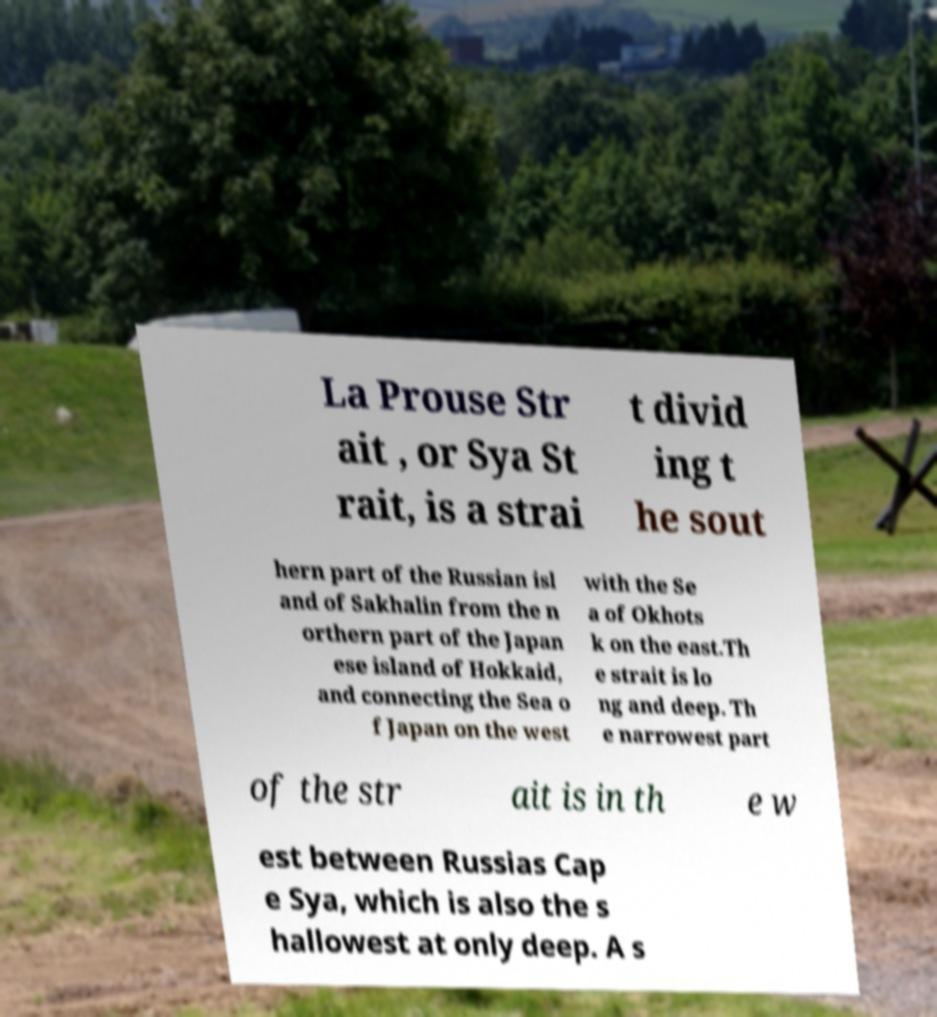For documentation purposes, I need the text within this image transcribed. Could you provide that? La Prouse Str ait , or Sya St rait, is a strai t divid ing t he sout hern part of the Russian isl and of Sakhalin from the n orthern part of the Japan ese island of Hokkaid, and connecting the Sea o f Japan on the west with the Se a of Okhots k on the east.Th e strait is lo ng and deep. Th e narrowest part of the str ait is in th e w est between Russias Cap e Sya, which is also the s hallowest at only deep. A s 